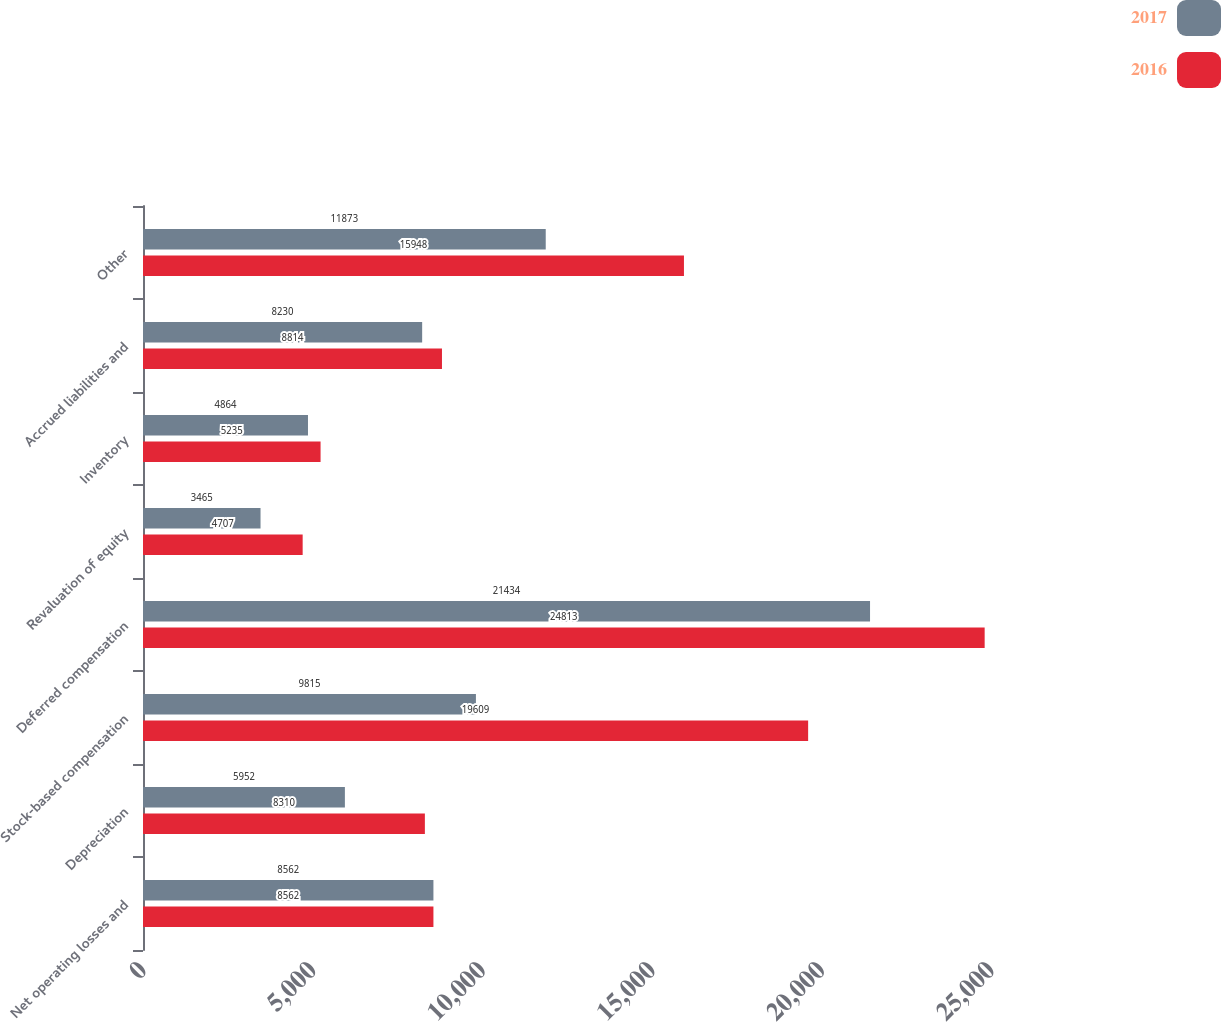<chart> <loc_0><loc_0><loc_500><loc_500><stacked_bar_chart><ecel><fcel>Net operating losses and<fcel>Depreciation<fcel>Stock-based compensation<fcel>Deferred compensation<fcel>Revaluation of equity<fcel>Inventory<fcel>Accrued liabilities and<fcel>Other<nl><fcel>2017<fcel>8562<fcel>5952<fcel>9815<fcel>21434<fcel>3465<fcel>4864<fcel>8230<fcel>11873<nl><fcel>2016<fcel>8562<fcel>8310<fcel>19609<fcel>24813<fcel>4707<fcel>5235<fcel>8814<fcel>15948<nl></chart> 